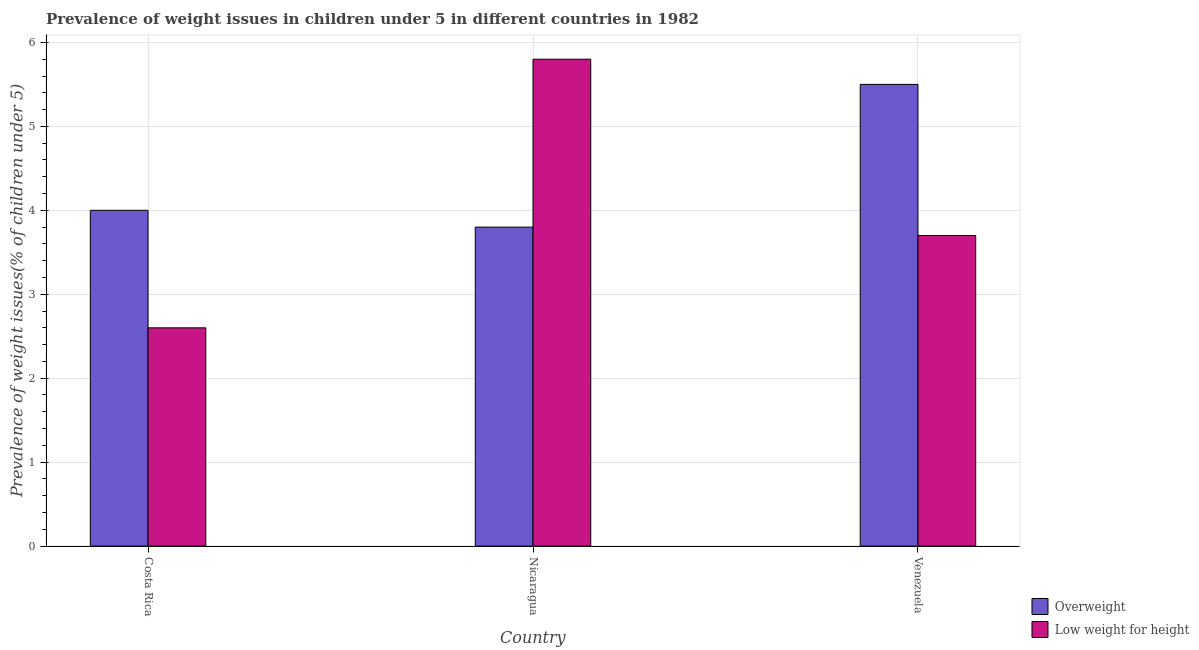Are the number of bars per tick equal to the number of legend labels?
Offer a terse response. Yes. How many bars are there on the 2nd tick from the left?
Offer a very short reply. 2. How many bars are there on the 1st tick from the right?
Provide a succinct answer. 2. What is the label of the 3rd group of bars from the left?
Your answer should be very brief. Venezuela. In how many cases, is the number of bars for a given country not equal to the number of legend labels?
Offer a very short reply. 0. What is the percentage of underweight children in Nicaragua?
Your answer should be compact. 5.8. Across all countries, what is the maximum percentage of underweight children?
Provide a short and direct response. 5.8. Across all countries, what is the minimum percentage of overweight children?
Keep it short and to the point. 3.8. In which country was the percentage of underweight children maximum?
Offer a terse response. Nicaragua. In which country was the percentage of underweight children minimum?
Give a very brief answer. Costa Rica. What is the total percentage of overweight children in the graph?
Provide a short and direct response. 13.3. What is the difference between the percentage of overweight children in Costa Rica and that in Venezuela?
Give a very brief answer. -1.5. What is the difference between the percentage of overweight children in Costa Rica and the percentage of underweight children in Nicaragua?
Provide a short and direct response. -1.8. What is the average percentage of overweight children per country?
Your answer should be very brief. 4.43. What is the difference between the percentage of underweight children and percentage of overweight children in Venezuela?
Your response must be concise. -1.8. In how many countries, is the percentage of underweight children greater than 5 %?
Provide a short and direct response. 1. What is the ratio of the percentage of underweight children in Costa Rica to that in Nicaragua?
Provide a succinct answer. 0.45. Is the percentage of overweight children in Costa Rica less than that in Venezuela?
Ensure brevity in your answer.  Yes. Is the difference between the percentage of overweight children in Costa Rica and Venezuela greater than the difference between the percentage of underweight children in Costa Rica and Venezuela?
Your answer should be compact. No. What is the difference between the highest and the second highest percentage of underweight children?
Your answer should be very brief. 2.1. What is the difference between the highest and the lowest percentage of underweight children?
Keep it short and to the point. 3.2. In how many countries, is the percentage of underweight children greater than the average percentage of underweight children taken over all countries?
Your answer should be compact. 1. What does the 2nd bar from the left in Venezuela represents?
Offer a very short reply. Low weight for height. What does the 2nd bar from the right in Costa Rica represents?
Provide a short and direct response. Overweight. How many bars are there?
Your answer should be compact. 6. How many countries are there in the graph?
Give a very brief answer. 3. What is the difference between two consecutive major ticks on the Y-axis?
Provide a succinct answer. 1. Does the graph contain any zero values?
Offer a terse response. No. Where does the legend appear in the graph?
Your answer should be very brief. Bottom right. How many legend labels are there?
Provide a succinct answer. 2. How are the legend labels stacked?
Offer a terse response. Vertical. What is the title of the graph?
Offer a terse response. Prevalence of weight issues in children under 5 in different countries in 1982. What is the label or title of the X-axis?
Keep it short and to the point. Country. What is the label or title of the Y-axis?
Provide a succinct answer. Prevalence of weight issues(% of children under 5). What is the Prevalence of weight issues(% of children under 5) of Overweight in Costa Rica?
Your answer should be very brief. 4. What is the Prevalence of weight issues(% of children under 5) of Low weight for height in Costa Rica?
Your answer should be compact. 2.6. What is the Prevalence of weight issues(% of children under 5) in Overweight in Nicaragua?
Provide a succinct answer. 3.8. What is the Prevalence of weight issues(% of children under 5) in Low weight for height in Nicaragua?
Offer a terse response. 5.8. What is the Prevalence of weight issues(% of children under 5) in Overweight in Venezuela?
Your answer should be very brief. 5.5. What is the Prevalence of weight issues(% of children under 5) of Low weight for height in Venezuela?
Give a very brief answer. 3.7. Across all countries, what is the maximum Prevalence of weight issues(% of children under 5) in Low weight for height?
Ensure brevity in your answer.  5.8. Across all countries, what is the minimum Prevalence of weight issues(% of children under 5) in Overweight?
Keep it short and to the point. 3.8. Across all countries, what is the minimum Prevalence of weight issues(% of children under 5) in Low weight for height?
Your answer should be compact. 2.6. What is the total Prevalence of weight issues(% of children under 5) in Low weight for height in the graph?
Offer a terse response. 12.1. What is the difference between the Prevalence of weight issues(% of children under 5) in Overweight in Costa Rica and that in Nicaragua?
Make the answer very short. 0.2. What is the difference between the Prevalence of weight issues(% of children under 5) of Low weight for height in Costa Rica and that in Nicaragua?
Offer a terse response. -3.2. What is the difference between the Prevalence of weight issues(% of children under 5) of Overweight in Costa Rica and that in Venezuela?
Provide a short and direct response. -1.5. What is the difference between the Prevalence of weight issues(% of children under 5) in Low weight for height in Costa Rica and that in Venezuela?
Your response must be concise. -1.1. What is the difference between the Prevalence of weight issues(% of children under 5) of Low weight for height in Nicaragua and that in Venezuela?
Your answer should be compact. 2.1. What is the difference between the Prevalence of weight issues(% of children under 5) of Overweight in Nicaragua and the Prevalence of weight issues(% of children under 5) of Low weight for height in Venezuela?
Make the answer very short. 0.1. What is the average Prevalence of weight issues(% of children under 5) of Overweight per country?
Your answer should be compact. 4.43. What is the average Prevalence of weight issues(% of children under 5) in Low weight for height per country?
Offer a terse response. 4.03. What is the difference between the Prevalence of weight issues(% of children under 5) of Overweight and Prevalence of weight issues(% of children under 5) of Low weight for height in Venezuela?
Offer a very short reply. 1.8. What is the ratio of the Prevalence of weight issues(% of children under 5) in Overweight in Costa Rica to that in Nicaragua?
Give a very brief answer. 1.05. What is the ratio of the Prevalence of weight issues(% of children under 5) of Low weight for height in Costa Rica to that in Nicaragua?
Make the answer very short. 0.45. What is the ratio of the Prevalence of weight issues(% of children under 5) in Overweight in Costa Rica to that in Venezuela?
Your answer should be very brief. 0.73. What is the ratio of the Prevalence of weight issues(% of children under 5) of Low weight for height in Costa Rica to that in Venezuela?
Provide a short and direct response. 0.7. What is the ratio of the Prevalence of weight issues(% of children under 5) in Overweight in Nicaragua to that in Venezuela?
Make the answer very short. 0.69. What is the ratio of the Prevalence of weight issues(% of children under 5) in Low weight for height in Nicaragua to that in Venezuela?
Provide a succinct answer. 1.57. What is the difference between the highest and the second highest Prevalence of weight issues(% of children under 5) in Low weight for height?
Offer a very short reply. 2.1. 